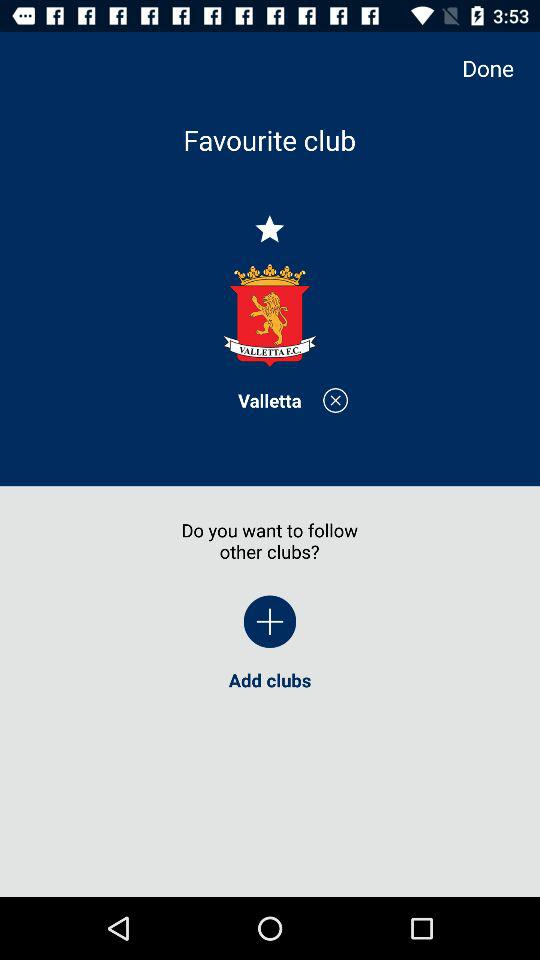How many clubs are the user following?
Answer the question using a single word or phrase. 1 